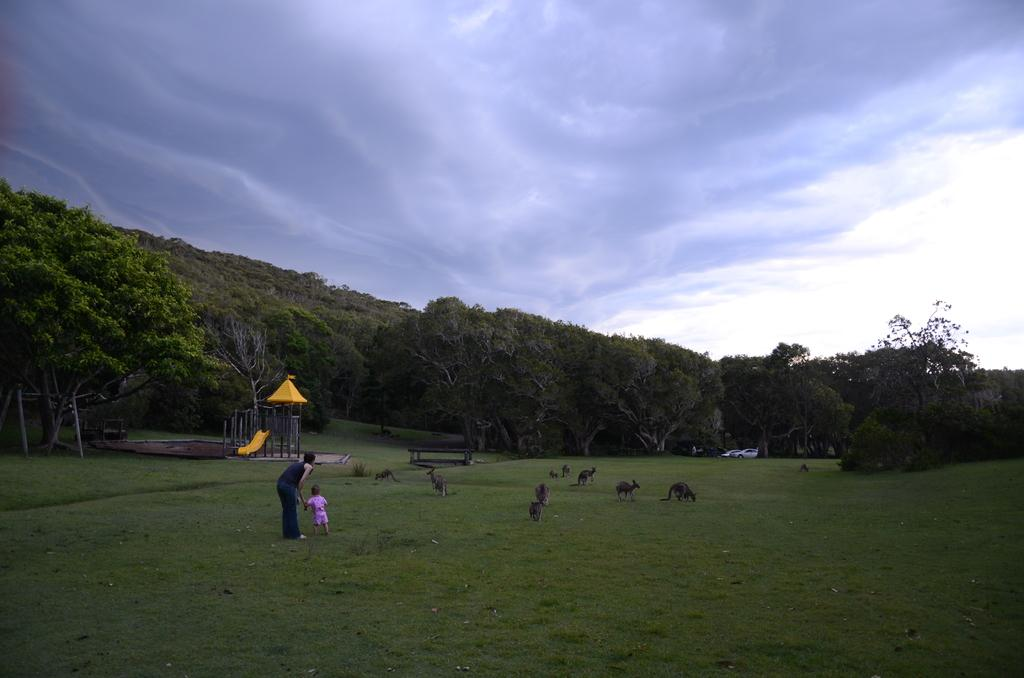What can be seen in the image? There are people, a cradle, animals, cars, trees, grass, and the sky visible in the image. Can you describe the setting of the image? The image appears to be set outdoors, as there are trees and grass present. What type of vehicles are in the image? Cars are in the image. What is the background of the image? The sky is visible in the background of the image. How does the image demonstrate the acoustics of the environment? The image does not demonstrate the acoustics of the environment, as it is a static visual representation and does not include any auditory information. 